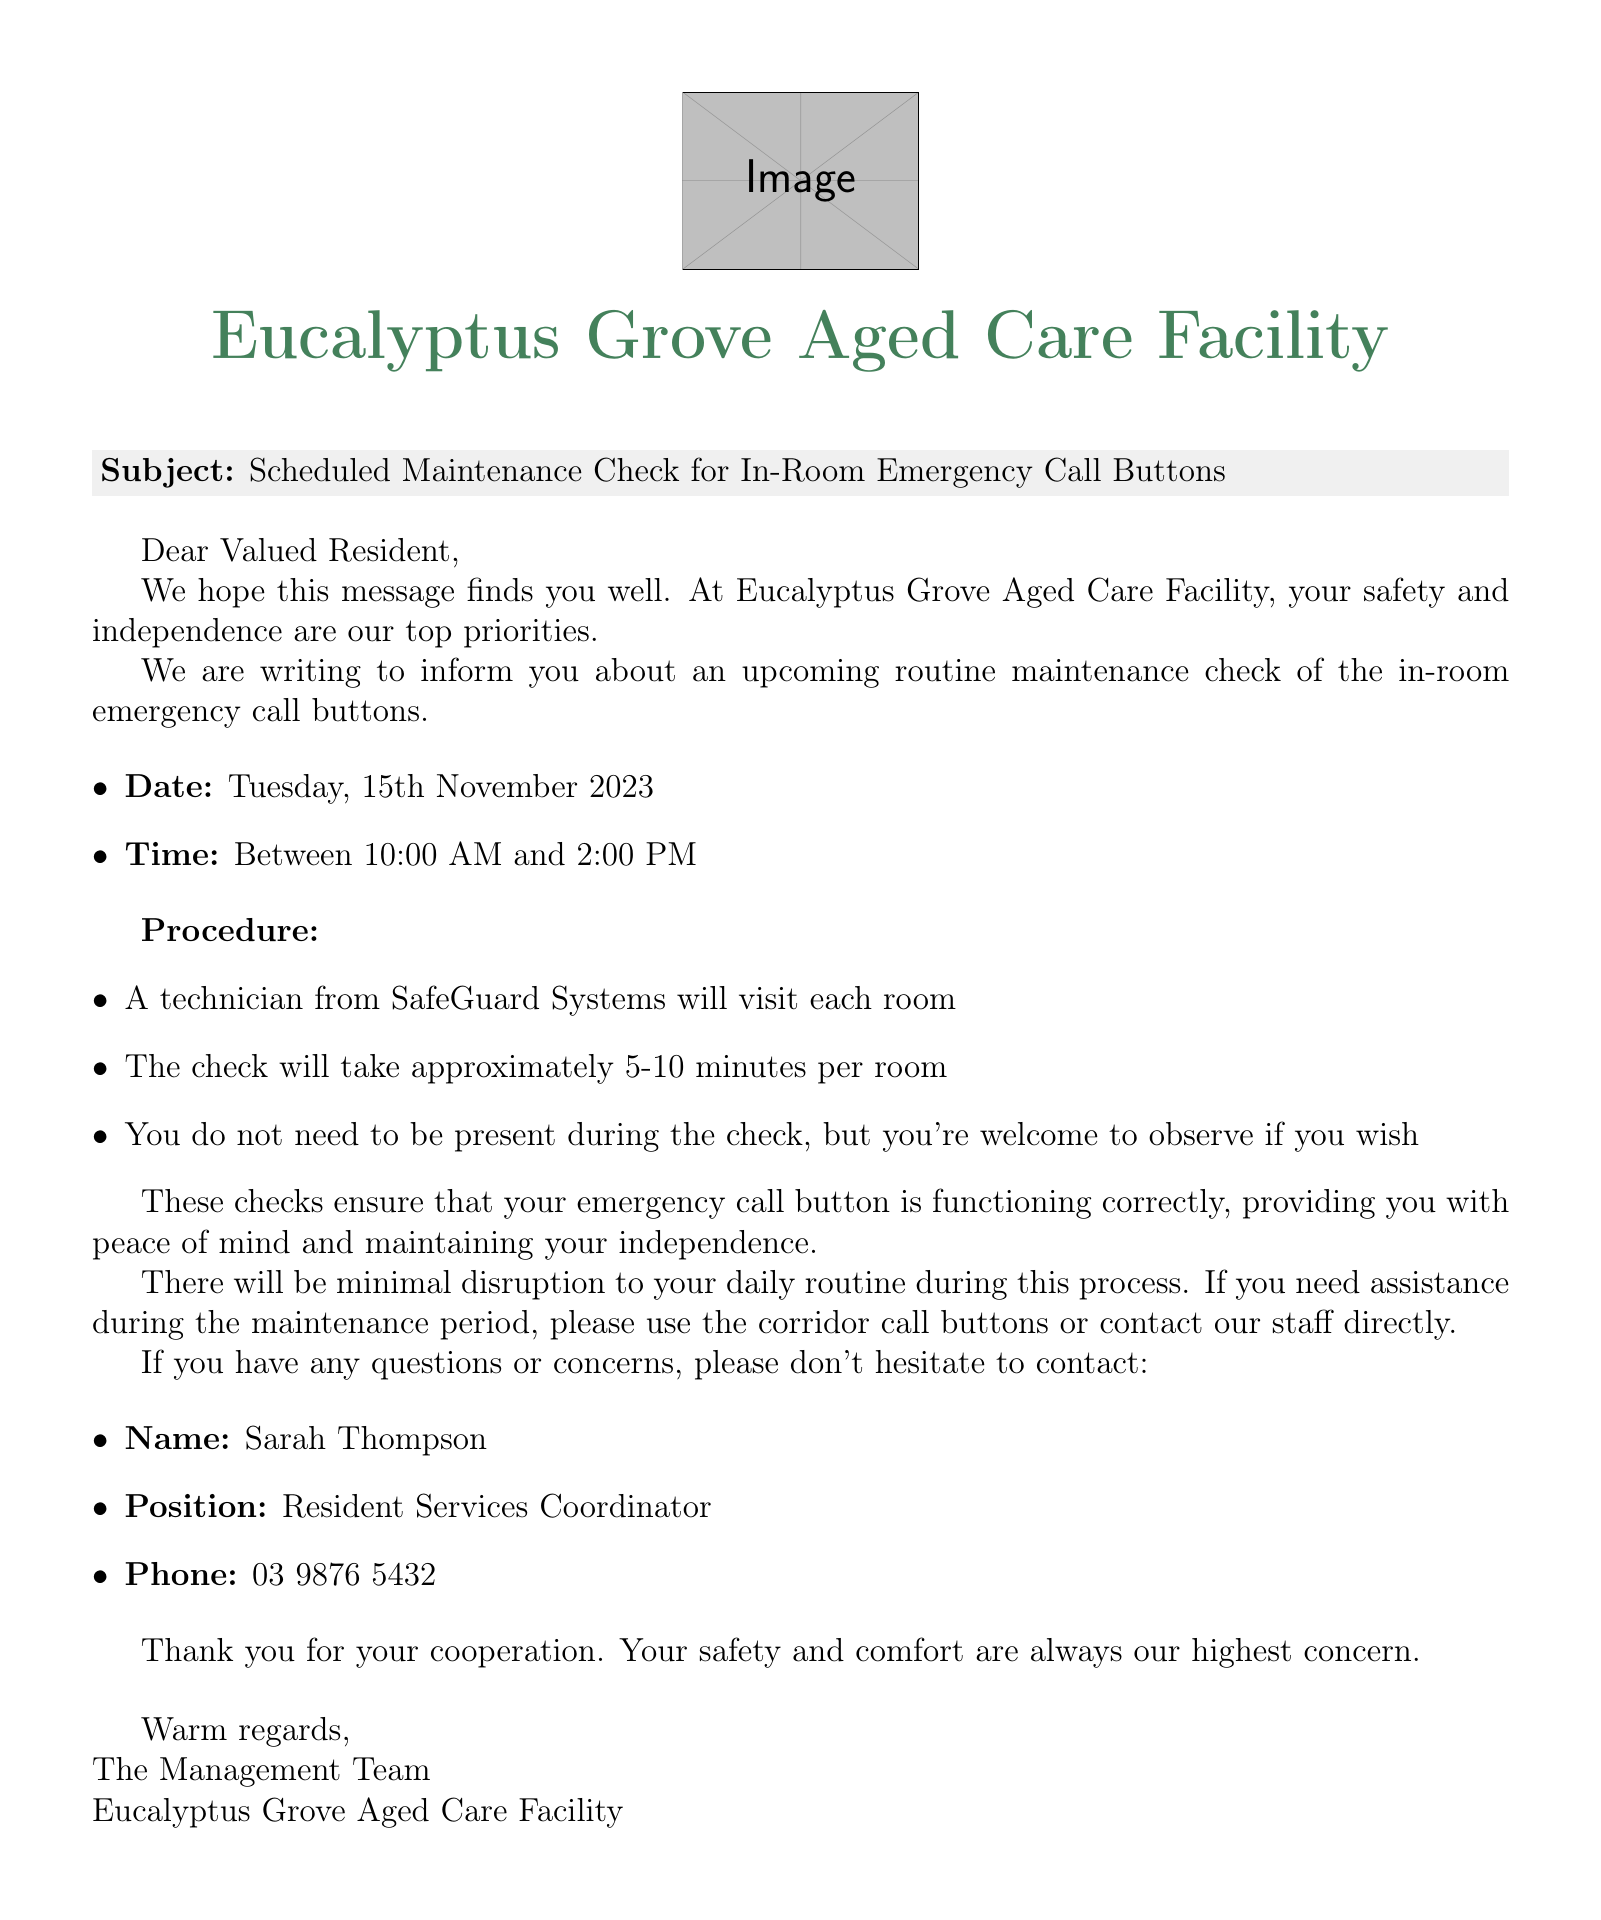What is the subject of the email? The subject of the email is specified at the beginning of the document.
Answer: Scheduled Maintenance Check for In-Room Emergency Call Buttons When is the maintenance check scheduled? The email states the specific date the maintenance check will take place.
Answer: Tuesday, 15th November 2023 What time will the maintenance check occur? The email provides a timeframe during which the maintenance check will take place.
Answer: Between 10:00 AM and 2:00 PM Who is the technician performing the check? The email includes the name of the technician's company tasked with the maintenance check.
Answer: SafeGuard Systems How long will the check take per room? The email outlines the expected duration for the check in each individual room.
Answer: Approximately 5-10 minutes What should residents do if they need assistance during maintenance? The email suggests alternative ways for residents to seek help during the maintenance period.
Answer: Use the corridor call buttons or contact our staff directly Is resident presence required during the check? The email clarifies whether residents need to be present for the maintenance check.
Answer: No 